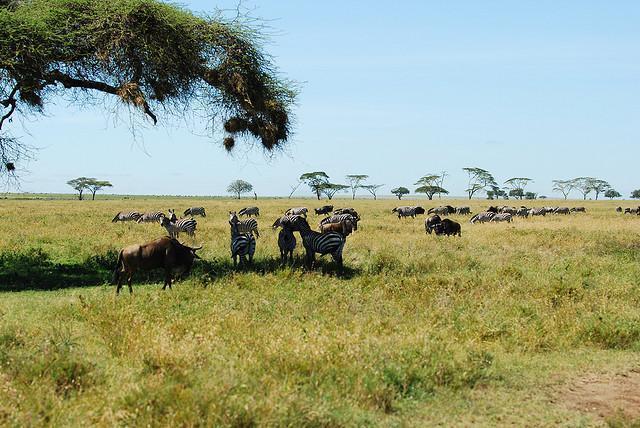How many different species are in this picture?
Give a very brief answer. 2. 